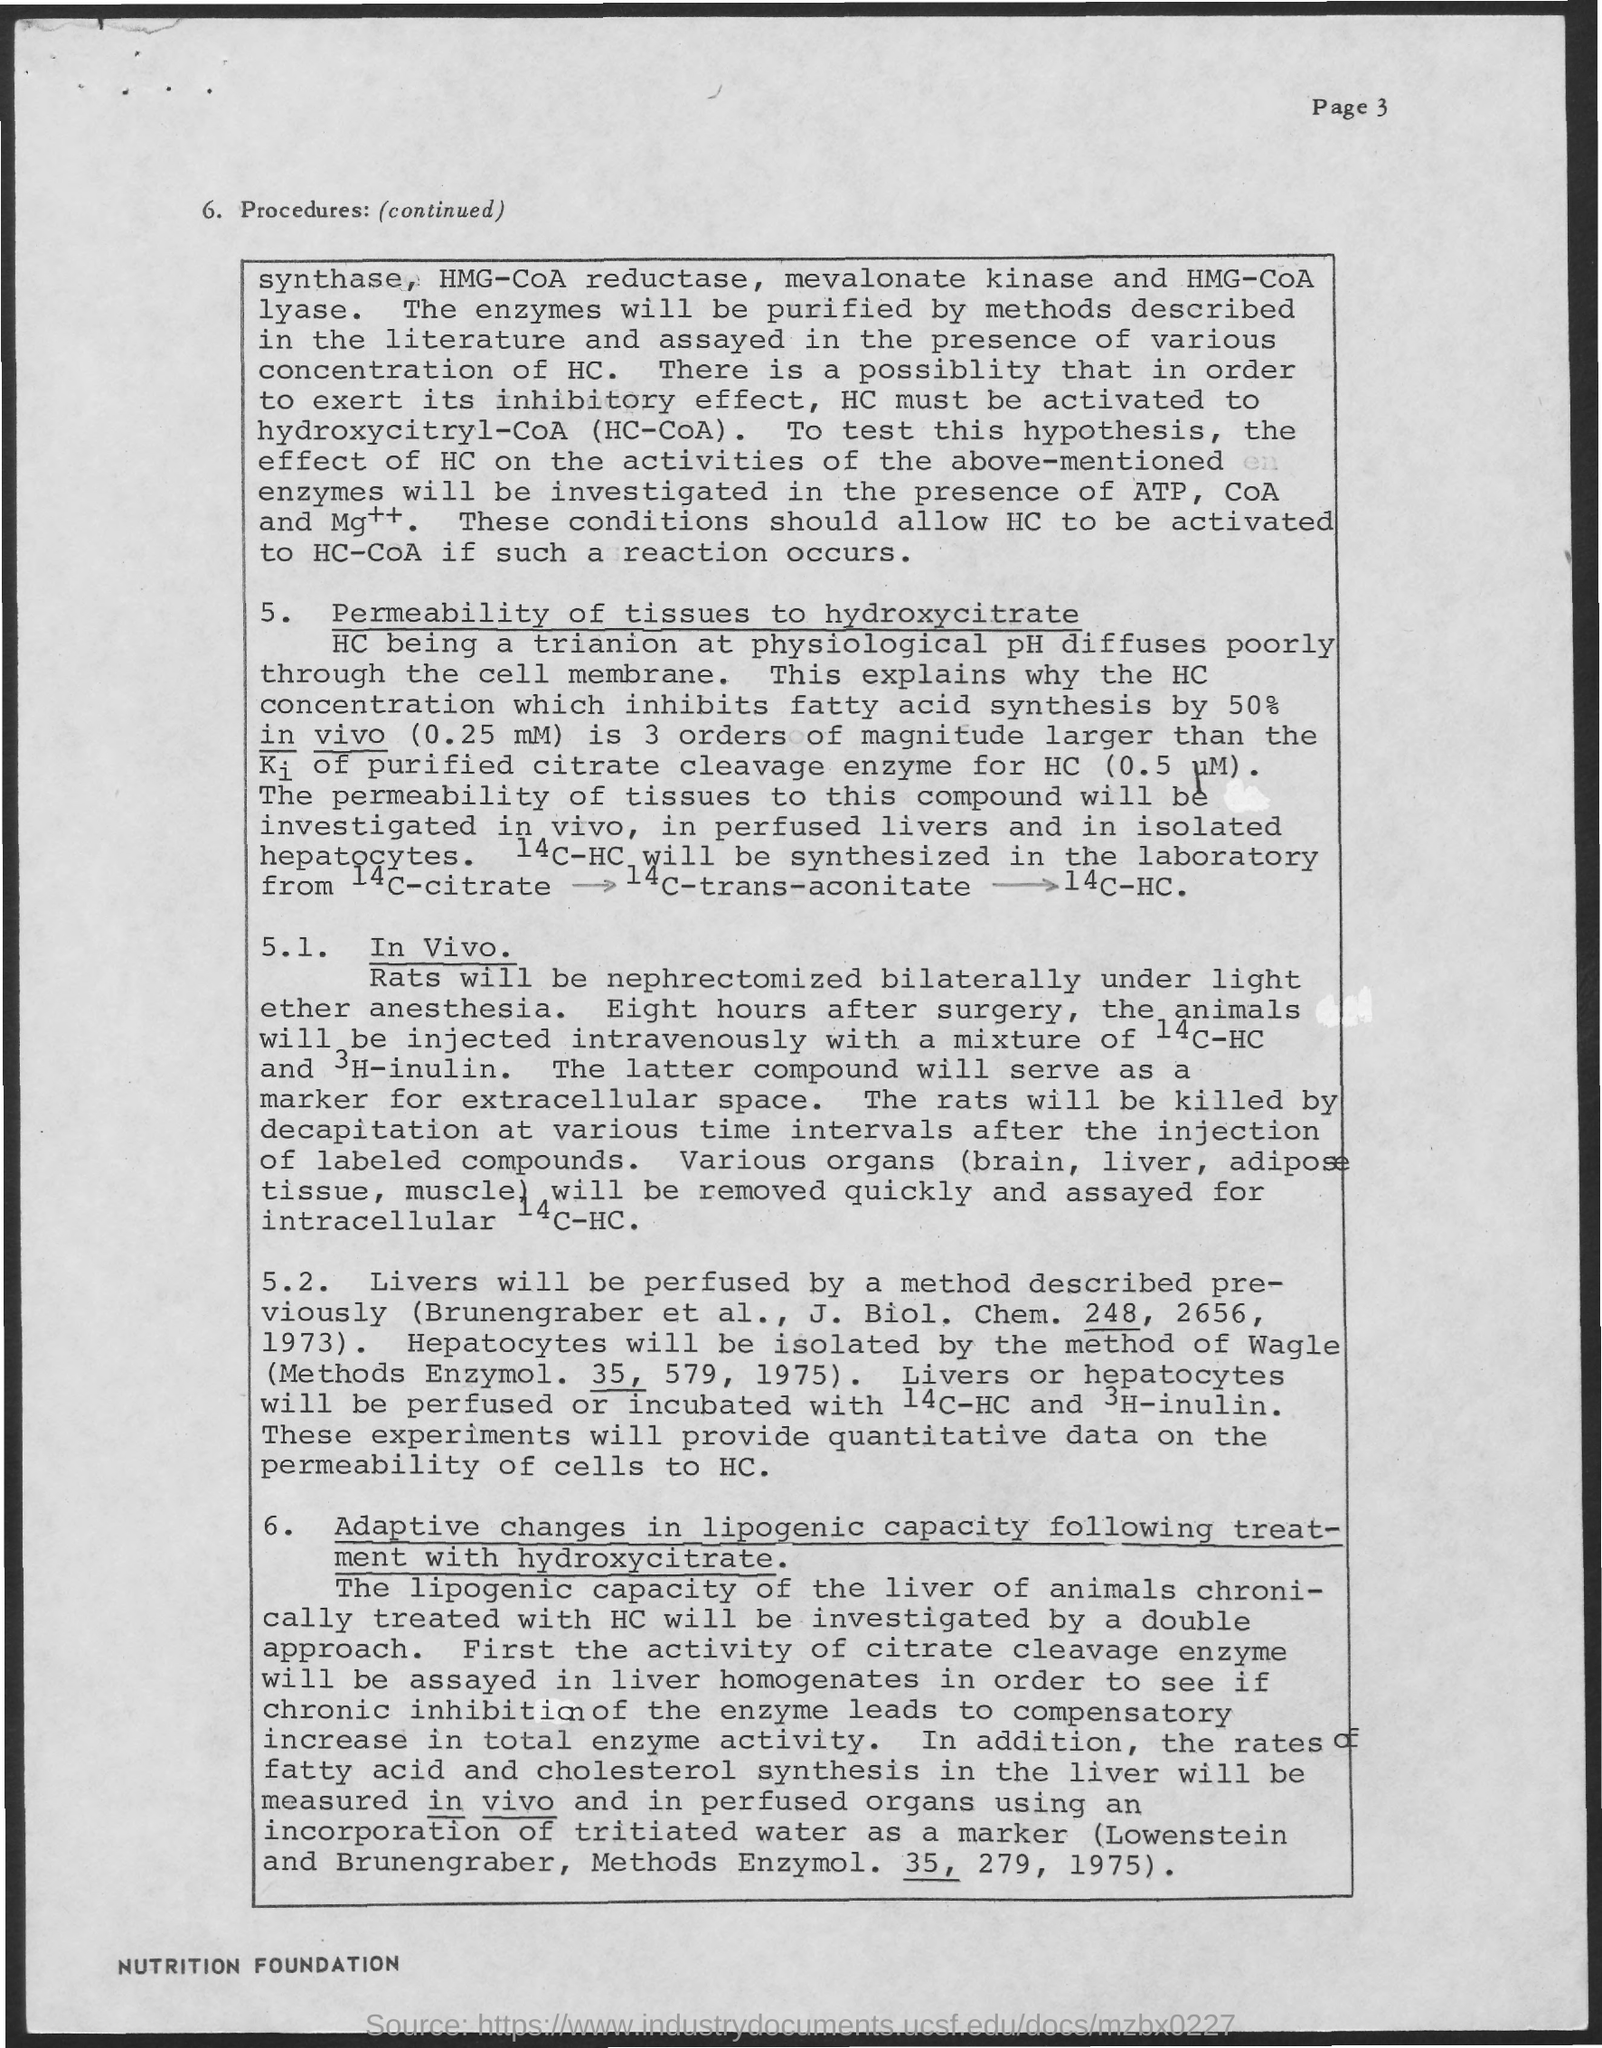How to find out the inhibitory effect of Enzyme?
Your answer should be very brief. HC must be activated to hydroxycitryl-CoA (HC-CoA). What is the method used to isolate Hepatocyte cells?
Provide a succinct answer. Method of wagle. 